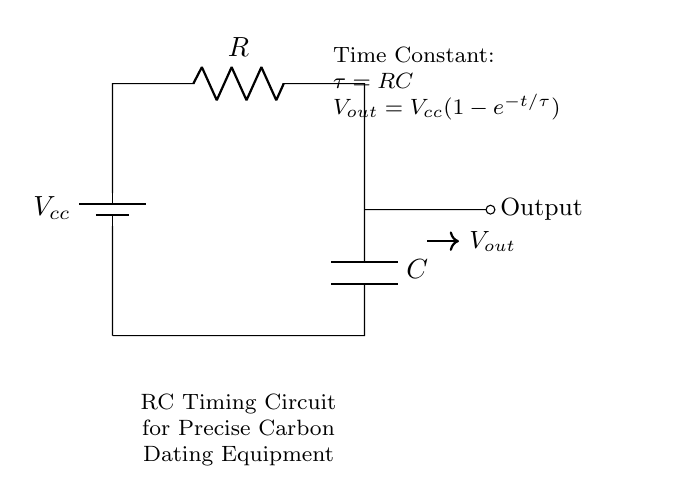What does the component labeled R represent? The component labeled R represents a resistor in the circuit, which is used to limit current and create a voltage drop.
Answer: Resistor What is the role of the component labeled C? The component labeled C represents a capacitor, which stores electrical energy and influences the timing of the circuit by determining the charge and discharge time.
Answer: Capacitor What is the voltage across the battery? The voltage across the battery is represented by Vcc, which supplies power to the circuit.
Answer: Vcc What is the time constant formula for this circuit? The time constant formula is given as τ = RC, where R is the resistance and C is the capacitance, identifying how quickly the circuit responds to changes in voltage.
Answer: τ = RC What is the output voltage expression? The output voltage expression is Vout = Vcc(1-e^{-t/τ}), indicating how the output voltage changes over time as the capacitor charges through the resistor.
Answer: Vout = Vcc(1-e^{-t/τ}) What happens to the output voltage when time t approaches infinity? As time t approaches infinity, Vout approaches Vcc, meaning the capacitor becomes fully charged and the output voltage stabilizes at the supply voltage level.
Answer: Vcc What effect does increasing the resistance R have on the time constant? Increasing the resistance R increases the time constant τ, which results in a slower charging and discharging rate of the capacitor, thus extending the time it takes for the voltage to change.
Answer: Increases τ 